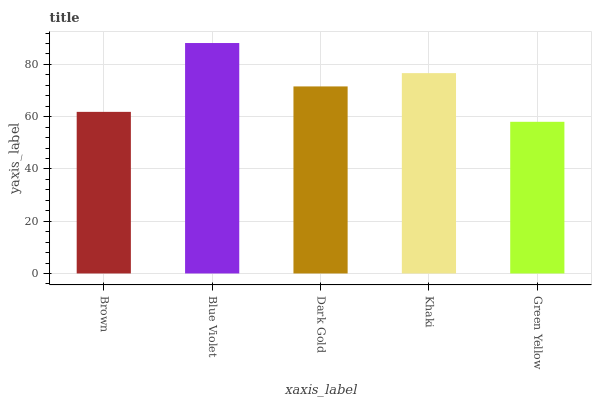Is Green Yellow the minimum?
Answer yes or no. Yes. Is Blue Violet the maximum?
Answer yes or no. Yes. Is Dark Gold the minimum?
Answer yes or no. No. Is Dark Gold the maximum?
Answer yes or no. No. Is Blue Violet greater than Dark Gold?
Answer yes or no. Yes. Is Dark Gold less than Blue Violet?
Answer yes or no. Yes. Is Dark Gold greater than Blue Violet?
Answer yes or no. No. Is Blue Violet less than Dark Gold?
Answer yes or no. No. Is Dark Gold the high median?
Answer yes or no. Yes. Is Dark Gold the low median?
Answer yes or no. Yes. Is Brown the high median?
Answer yes or no. No. Is Blue Violet the low median?
Answer yes or no. No. 